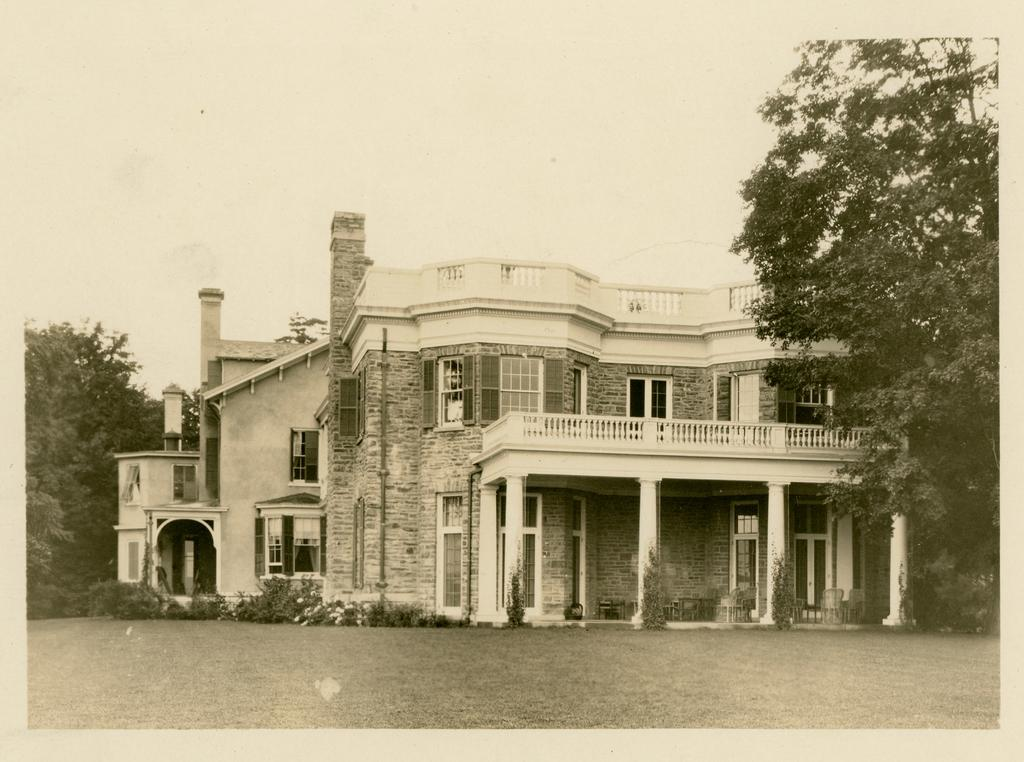What type of structure is present in the image? There is a building in the image. What type of vegetation can be seen in the image? There are green color trees in the image. What is visible at the top of the image? The sky is visible at the top of the image. What type of glass is used to make the roof of the building in the image? There is no mention of a roof in the image, nor is there any information about the building's construction materials. 